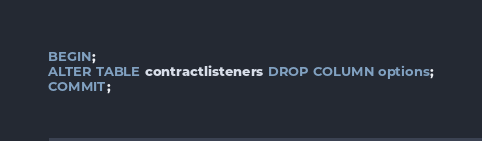Convert code to text. <code><loc_0><loc_0><loc_500><loc_500><_SQL_>BEGIN;
ALTER TABLE contractlisteners DROP COLUMN options;
COMMIT;</code> 